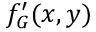<formula> <loc_0><loc_0><loc_500><loc_500>f _ { G } ^ { \prime } ( x , y )</formula> 